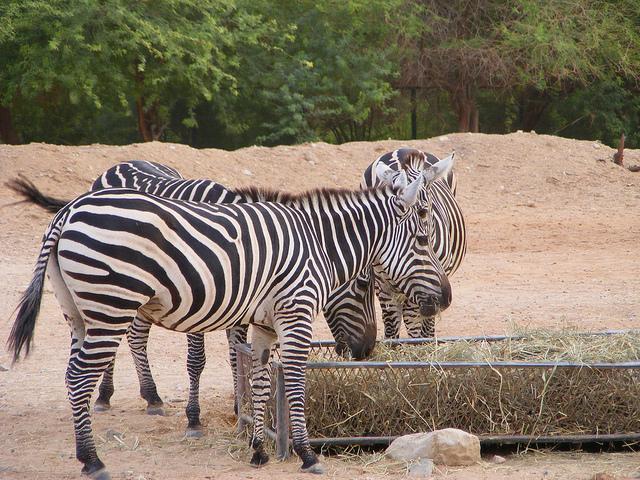How many zebras are there?
Give a very brief answer. 3. How many animals in the picture?
Give a very brief answer. 3. How many zebras are drinking?
Give a very brief answer. 3. How many animals are in this picture?
Give a very brief answer. 3. 